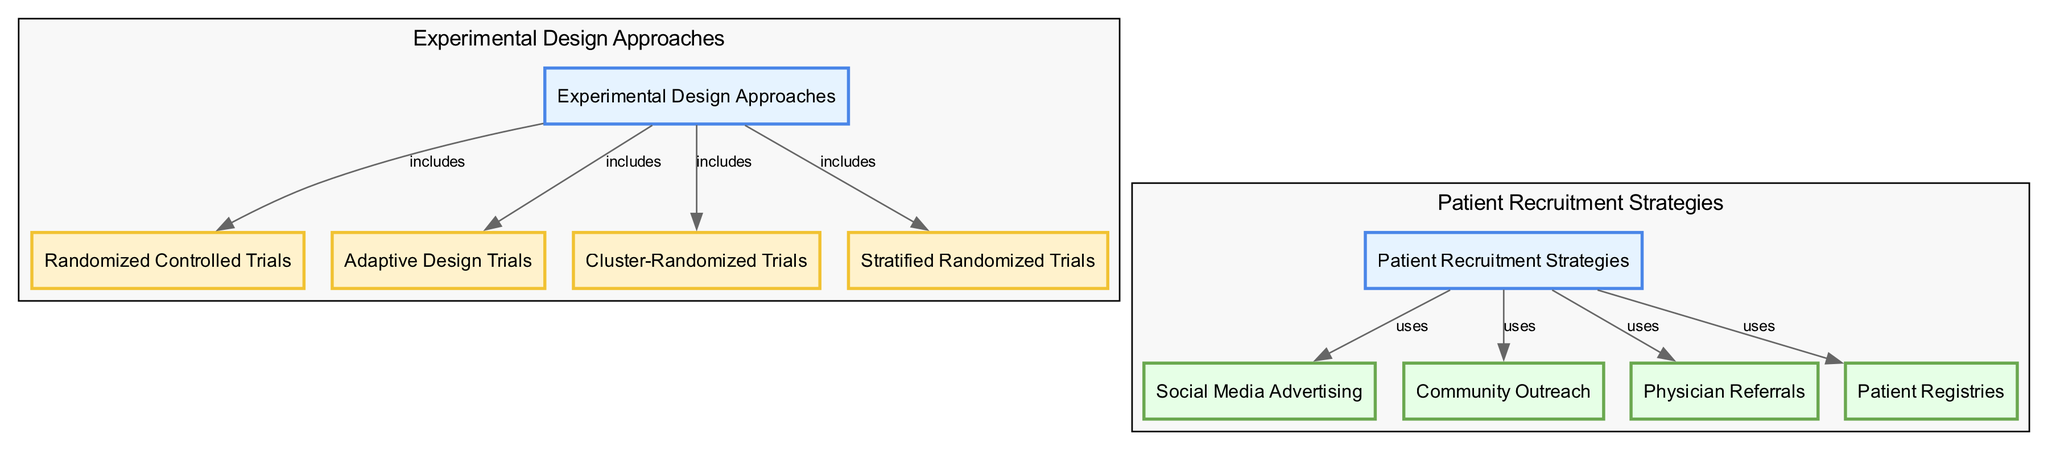What are the four experimental design approaches included in the diagram? By examining the nodes labeled "Experimental Design Approaches," we identify four specific approaches: Randomized Controlled Trials, Adaptive Design Trials, Cluster-Randomized Trials, and Stratified Randomized Trials.
Answer: Randomized Controlled Trials, Adaptive Design Trials, Cluster-Randomized Trials, Stratified Randomized Trials How many patient recruitment strategies are listed in the diagram? Looking at the nodes connected to "Patient Recruitment Strategies," we find four strategies highlighted: Social Media Advertising, Community Outreach, Physician Referrals, and Patient Registries. Counting these gives us a total of four strategies.
Answer: Four What type of trial is indicated by "Patient Registries"? To determine this, I will look for connections between the "Patient Registries" node and the nodes provided. Since "Patient Registries" is linked under "Patient Recruitment Strategies" but has no direct linkage labeled as a design method, it falls within recruitment strategies rather than an experimental design type.
Answer: Recruitment strategy Which recruitment strategy is associated with the use of social media? The diagram shows "Social Media Advertising" as a direct connection under "Patient Recruitment Strategies," indicating that it is specifically one of the methods used for recruitment in clinical trials.
Answer: Social Media Advertising How is cluster randomization related to recruitment strategies? Although "Cluster-Randomized Trials" is an experimental design method, there are no direct lines or labels indicating a relationship with any specific recruitment strategy in the diagram. Hence, cluster randomization is predominantly a design method used independently from the recruitment strategies, though it may still be applied in conjunction with them.
Answer: No direct relationship Which recruitment strategy connects to physician referrals? Upon reviewing the edges stemming from "Physician Referrals," it is clear that it is directly connected as a strategy used under "Patient Recruitment Strategies."
Answer: Physician Referrals What is the primary focus of the diagram? The diagram primarily focuses on two concepts: Experimental Design Approaches and Patient Recruitment Strategies, illustrating how various methods and strategies interrelate within clinical trials.
Answer: Experimental Design Approaches and Patient Recruitment Strategies What types of experimental designs are used within the context of patient recruitment? The relationships illustrated show that the experimental designs (randomization, adaptive design, cluster randomization, and stratified randomization) are categorized under one concept, while recruitment strategies are categorized separately, emphasizing no direct linkage between them in terms of reciprocal use.
Answer: No direct linkage 